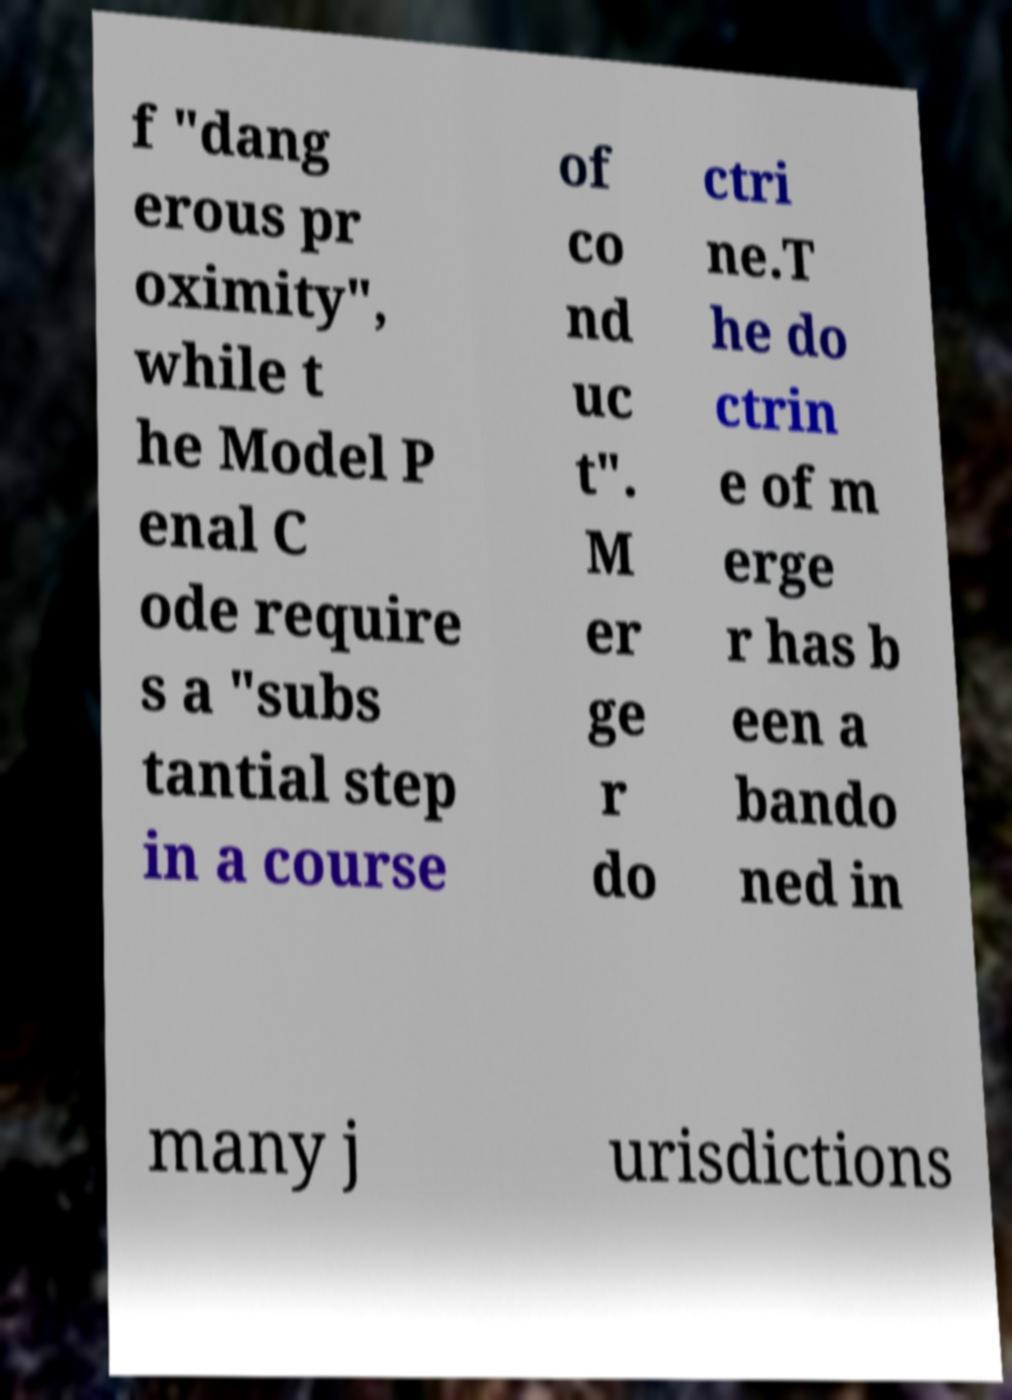I need the written content from this picture converted into text. Can you do that? f "dang erous pr oximity", while t he Model P enal C ode require s a "subs tantial step in a course of co nd uc t". M er ge r do ctri ne.T he do ctrin e of m erge r has b een a bando ned in many j urisdictions 